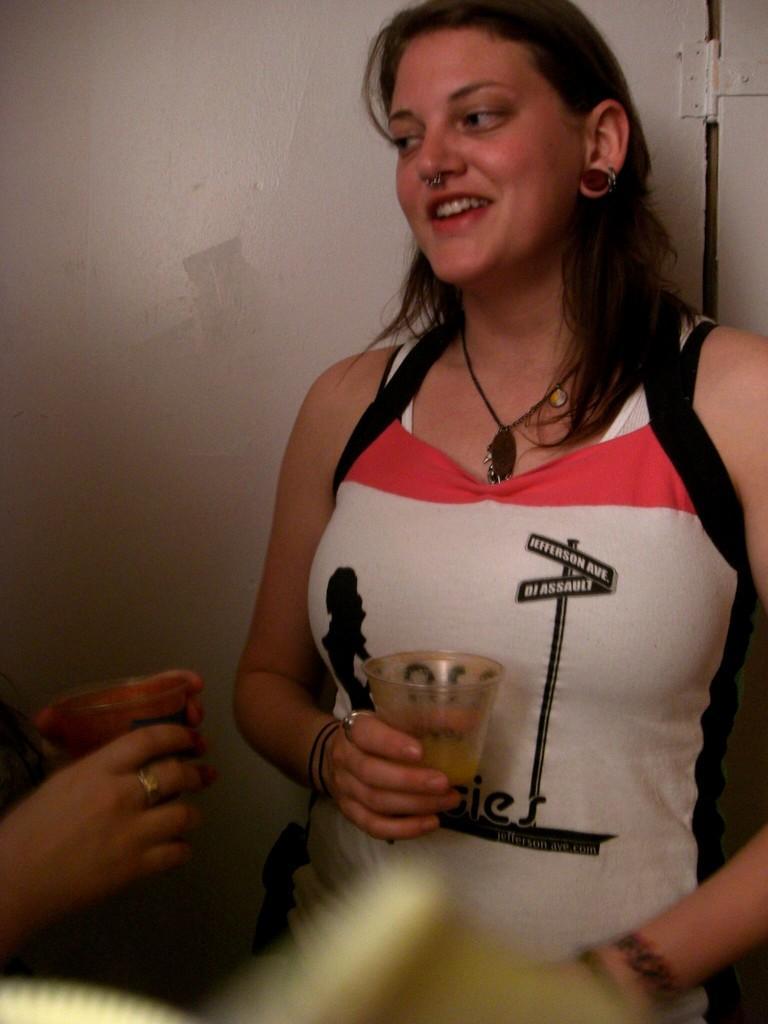Please provide a concise description of this image. In the foreground of this image, there is a woman standing and holding a glass and on the left, there is a person holding a glass. Behind them, there is a wall. 